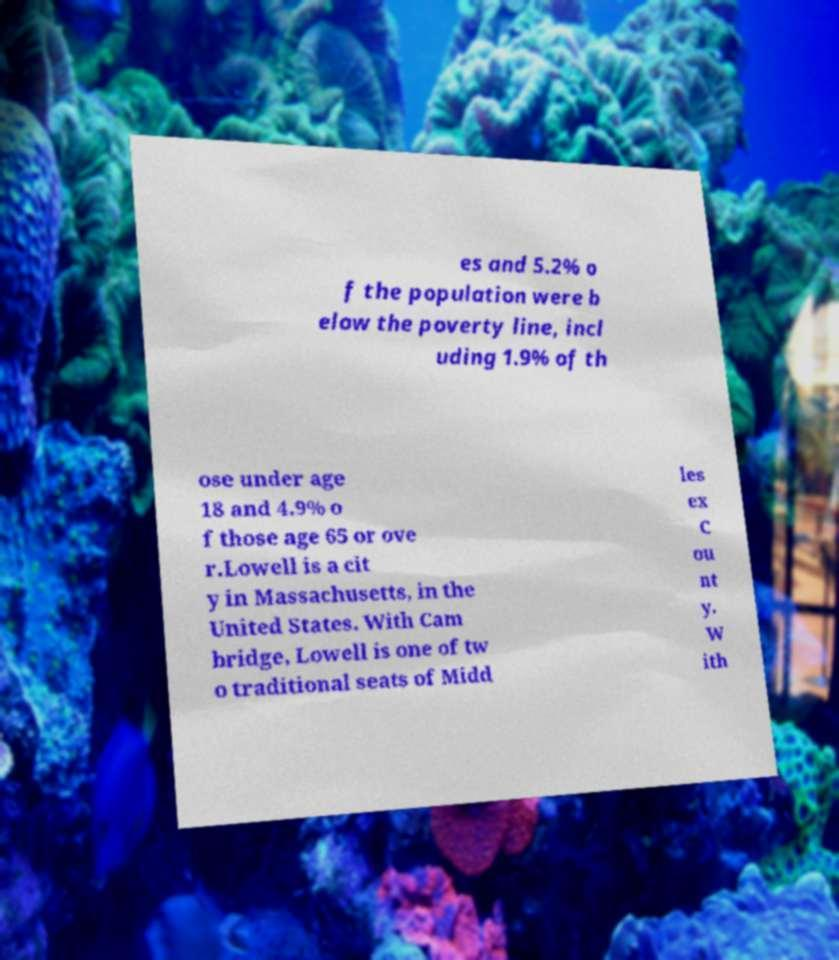Can you accurately transcribe the text from the provided image for me? es and 5.2% o f the population were b elow the poverty line, incl uding 1.9% of th ose under age 18 and 4.9% o f those age 65 or ove r.Lowell is a cit y in Massachusetts, in the United States. With Cam bridge, Lowell is one of tw o traditional seats of Midd les ex C ou nt y. W ith 